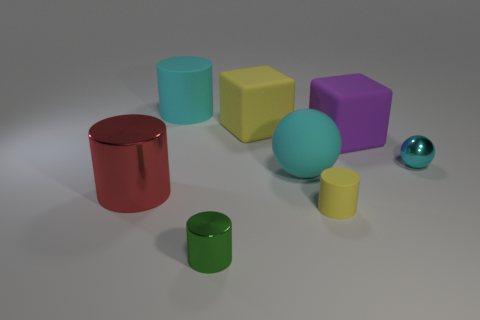Subtract 1 cylinders. How many cylinders are left? 3 Subtract all green cylinders. Subtract all red cubes. How many cylinders are left? 3 Add 1 big cyan matte balls. How many objects exist? 9 Subtract all balls. How many objects are left? 6 Subtract all red cylinders. Subtract all big cyan balls. How many objects are left? 6 Add 2 large rubber things. How many large rubber things are left? 6 Add 1 large cyan blocks. How many large cyan blocks exist? 1 Subtract 0 yellow spheres. How many objects are left? 8 